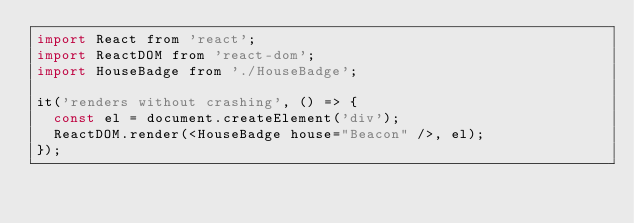<code> <loc_0><loc_0><loc_500><loc_500><_JavaScript_>import React from 'react';
import ReactDOM from 'react-dom';
import HouseBadge from './HouseBadge';

it('renders without crashing', () => {
  const el = document.createElement('div');
  ReactDOM.render(<HouseBadge house="Beacon" />, el);
});
</code> 